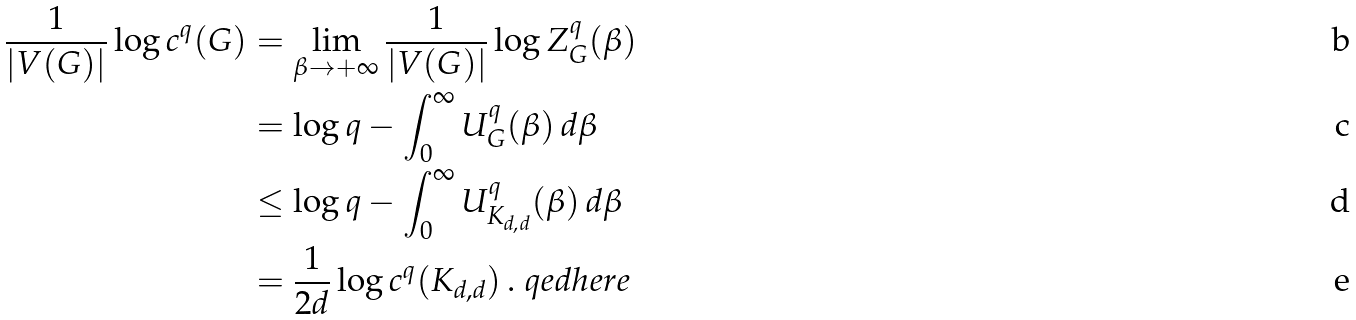<formula> <loc_0><loc_0><loc_500><loc_500>\frac { 1 } { | V ( G ) | } \log c ^ { q } ( G ) & = \lim _ { \beta \to + \infty } \frac { 1 } { | V ( G ) | } \log Z ^ { q } _ { G } ( \beta ) \\ & = \log q - \int _ { 0 } ^ { \infty } U ^ { q } _ { G } ( \beta ) \, d \beta \\ & \leq \log q - \int _ { 0 } ^ { \infty } U ^ { q } _ { K _ { d , d } } ( \beta ) \, d \beta \\ & = \frac { 1 } { 2 d } \log c ^ { q } ( K _ { d , d } ) \, . \ q e d h e r e</formula> 